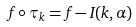<formula> <loc_0><loc_0><loc_500><loc_500>f \circ \tau _ { k } = f - I ( k , \alpha )</formula> 